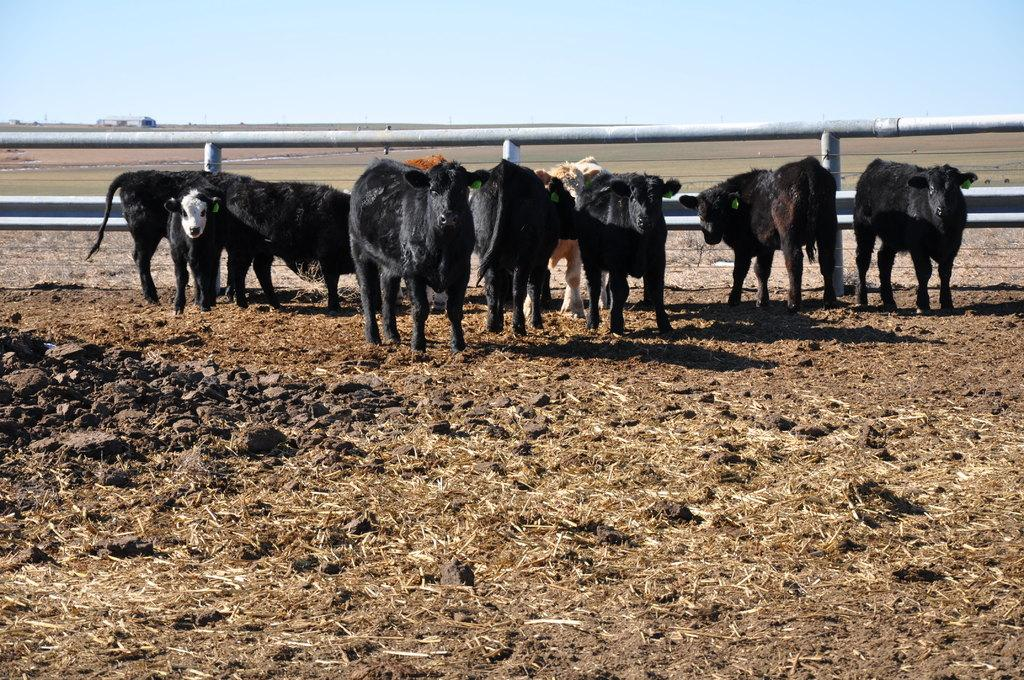What type of surface is visible in the image? There is soil visible in the image. What other living beings can be seen in the image? There are animals in the image. What is used to enclose or separate the area in the image? There is fencing in the image. What can be seen in the distance in the image? The sky is visible in the background of the image. Where is the grandfather sitting with his fan in the image? There is no grandfather or fan present in the image. What type of train can be seen passing by in the image? There is no train visible in the image. 